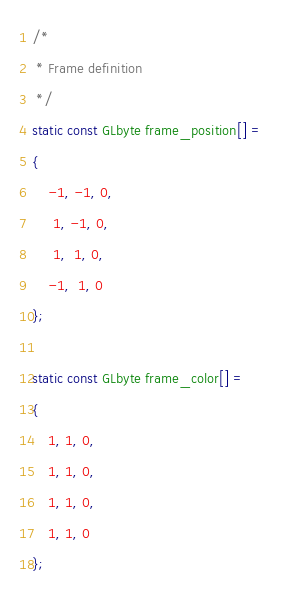Convert code to text. <code><loc_0><loc_0><loc_500><loc_500><_C_>/*
 * Frame definition
 */
static const GLbyte frame_position[] =
{
    -1, -1, 0,
	 1, -1, 0,
	 1,  1, 0,
	-1,  1, 0
};

static const GLbyte frame_color[] =
{
	1, 1, 0,
	1, 1, 0,
	1, 1, 0,
	1, 1, 0
};
</code> 